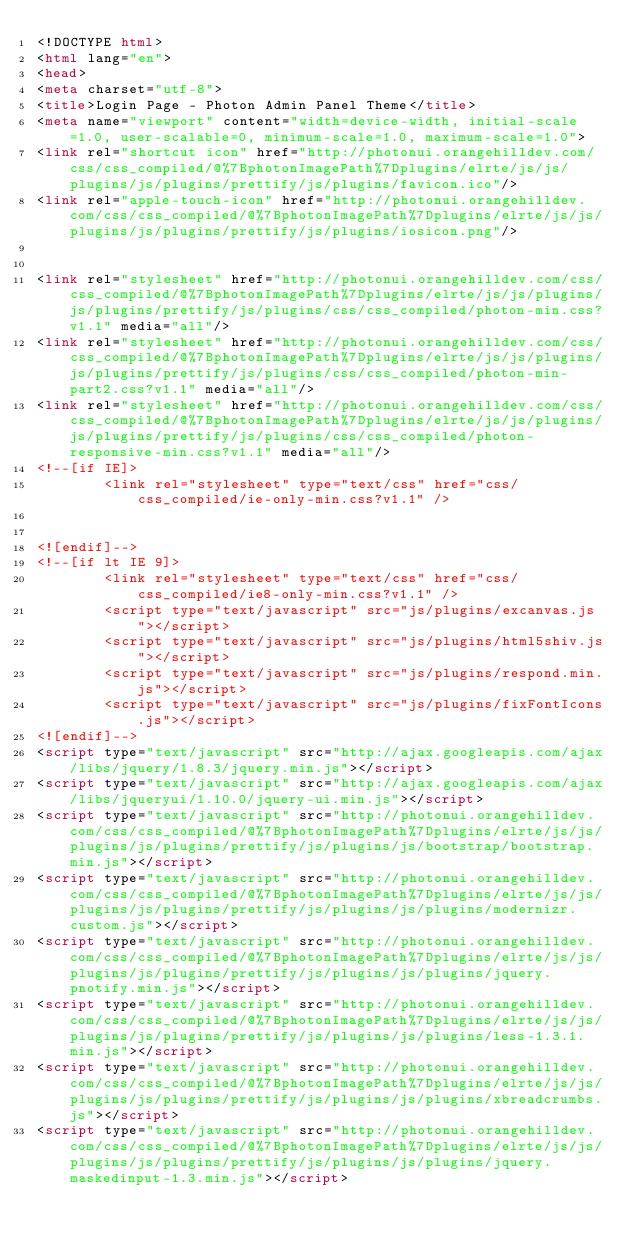Convert code to text. <code><loc_0><loc_0><loc_500><loc_500><_HTML_><!DOCTYPE html>
<html lang="en">
<head>
<meta charset="utf-8">
<title>Login Page - Photon Admin Panel Theme</title>
<meta name="viewport" content="width=device-width, initial-scale=1.0, user-scalable=0, minimum-scale=1.0, maximum-scale=1.0">
<link rel="shortcut icon" href="http://photonui.orangehilldev.com/css/css_compiled/@%7BphotonImagePath%7Dplugins/elrte/js/js/plugins/js/plugins/prettify/js/plugins/favicon.ico"/>
<link rel="apple-touch-icon" href="http://photonui.orangehilldev.com/css/css_compiled/@%7BphotonImagePath%7Dplugins/elrte/js/js/plugins/js/plugins/prettify/js/plugins/iosicon.png"/>
 
   
<link rel="stylesheet" href="http://photonui.orangehilldev.com/css/css_compiled/@%7BphotonImagePath%7Dplugins/elrte/js/js/plugins/js/plugins/prettify/js/plugins/css/css_compiled/photon-min.css?v1.1" media="all"/>
<link rel="stylesheet" href="http://photonui.orangehilldev.com/css/css_compiled/@%7BphotonImagePath%7Dplugins/elrte/js/js/plugins/js/plugins/prettify/js/plugins/css/css_compiled/photon-min-part2.css?v1.1" media="all"/>
<link rel="stylesheet" href="http://photonui.orangehilldev.com/css/css_compiled/@%7BphotonImagePath%7Dplugins/elrte/js/js/plugins/js/plugins/prettify/js/plugins/css/css_compiled/photon-responsive-min.css?v1.1" media="all"/>
<!--[if IE]>
        <link rel="stylesheet" type="text/css" href="css/css_compiled/ie-only-min.css?v1.1" />
        

<![endif]-->
<!--[if lt IE 9]>
        <link rel="stylesheet" type="text/css" href="css/css_compiled/ie8-only-min.css?v1.1" />
        <script type="text/javascript" src="js/plugins/excanvas.js"></script>
        <script type="text/javascript" src="js/plugins/html5shiv.js"></script>
        <script type="text/javascript" src="js/plugins/respond.min.js"></script>
        <script type="text/javascript" src="js/plugins/fixFontIcons.js"></script>
<![endif]-->
<script type="text/javascript" src="http://ajax.googleapis.com/ajax/libs/jquery/1.8.3/jquery.min.js"></script>
<script type="text/javascript" src="http://ajax.googleapis.com/ajax/libs/jqueryui/1.10.0/jquery-ui.min.js"></script>
<script type="text/javascript" src="http://photonui.orangehilldev.com/css/css_compiled/@%7BphotonImagePath%7Dplugins/elrte/js/js/plugins/js/plugins/prettify/js/plugins/js/bootstrap/bootstrap.min.js"></script>
<script type="text/javascript" src="http://photonui.orangehilldev.com/css/css_compiled/@%7BphotonImagePath%7Dplugins/elrte/js/js/plugins/js/plugins/prettify/js/plugins/js/plugins/modernizr.custom.js"></script>
<script type="text/javascript" src="http://photonui.orangehilldev.com/css/css_compiled/@%7BphotonImagePath%7Dplugins/elrte/js/js/plugins/js/plugins/prettify/js/plugins/js/plugins/jquery.pnotify.min.js"></script>
<script type="text/javascript" src="http://photonui.orangehilldev.com/css/css_compiled/@%7BphotonImagePath%7Dplugins/elrte/js/js/plugins/js/plugins/prettify/js/plugins/js/plugins/less-1.3.1.min.js"></script>
<script type="text/javascript" src="http://photonui.orangehilldev.com/css/css_compiled/@%7BphotonImagePath%7Dplugins/elrte/js/js/plugins/js/plugins/prettify/js/plugins/js/plugins/xbreadcrumbs.js"></script>
<script type="text/javascript" src="http://photonui.orangehilldev.com/css/css_compiled/@%7BphotonImagePath%7Dplugins/elrte/js/js/plugins/js/plugins/prettify/js/plugins/js/plugins/jquery.maskedinput-1.3.min.js"></script></code> 